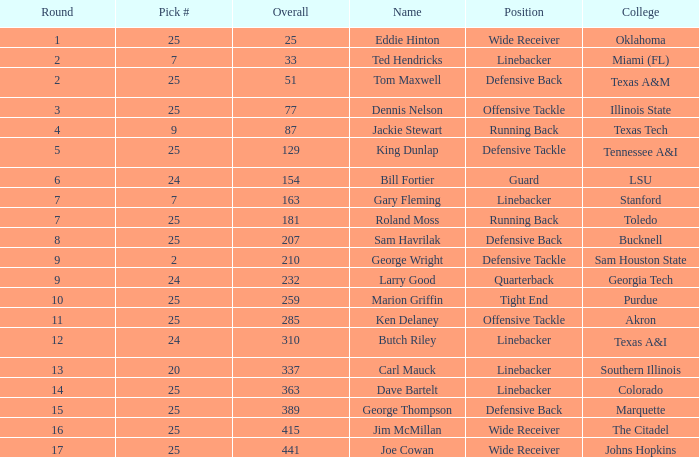Select # of 25, and a total of 207 is called what? Sam Havrilak. Would you mind parsing the complete table? {'header': ['Round', 'Pick #', 'Overall', 'Name', 'Position', 'College'], 'rows': [['1', '25', '25', 'Eddie Hinton', 'Wide Receiver', 'Oklahoma'], ['2', '7', '33', 'Ted Hendricks', 'Linebacker', 'Miami (FL)'], ['2', '25', '51', 'Tom Maxwell', 'Defensive Back', 'Texas A&M'], ['3', '25', '77', 'Dennis Nelson', 'Offensive Tackle', 'Illinois State'], ['4', '9', '87', 'Jackie Stewart', 'Running Back', 'Texas Tech'], ['5', '25', '129', 'King Dunlap', 'Defensive Tackle', 'Tennessee A&I'], ['6', '24', '154', 'Bill Fortier', 'Guard', 'LSU'], ['7', '7', '163', 'Gary Fleming', 'Linebacker', 'Stanford'], ['7', '25', '181', 'Roland Moss', 'Running Back', 'Toledo'], ['8', '25', '207', 'Sam Havrilak', 'Defensive Back', 'Bucknell'], ['9', '2', '210', 'George Wright', 'Defensive Tackle', 'Sam Houston State'], ['9', '24', '232', 'Larry Good', 'Quarterback', 'Georgia Tech'], ['10', '25', '259', 'Marion Griffin', 'Tight End', 'Purdue'], ['11', '25', '285', 'Ken Delaney', 'Offensive Tackle', 'Akron'], ['12', '24', '310', 'Butch Riley', 'Linebacker', 'Texas A&I'], ['13', '20', '337', 'Carl Mauck', 'Linebacker', 'Southern Illinois'], ['14', '25', '363', 'Dave Bartelt', 'Linebacker', 'Colorado'], ['15', '25', '389', 'George Thompson', 'Defensive Back', 'Marquette'], ['16', '25', '415', 'Jim McMillan', 'Wide Receiver', 'The Citadel'], ['17', '25', '441', 'Joe Cowan', 'Wide Receiver', 'Johns Hopkins']]} 